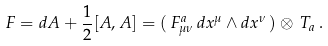Convert formula to latex. <formula><loc_0><loc_0><loc_500><loc_500>F = d A + \frac { 1 } { 2 } [ A , A ] = ( \, F ^ { a } _ { \mu \nu } \, d x ^ { \mu } \wedge d x ^ { \nu } \, ) \otimes \, T _ { a } \, .</formula> 